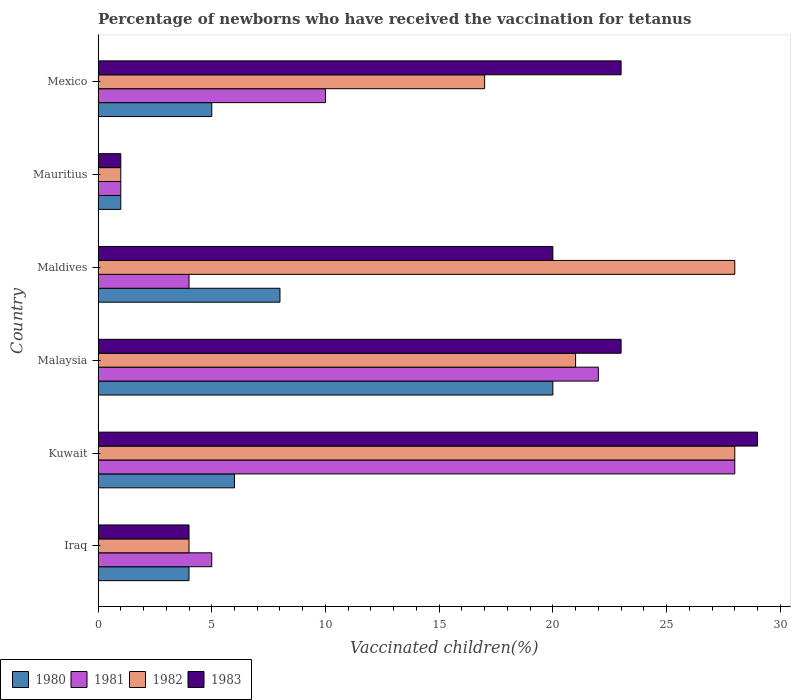How many different coloured bars are there?
Your answer should be very brief. 4. How many groups of bars are there?
Your answer should be compact. 6. How many bars are there on the 3rd tick from the top?
Offer a very short reply. 4. What is the label of the 3rd group of bars from the top?
Your response must be concise. Maldives. What is the percentage of vaccinated children in 1981 in Kuwait?
Offer a very short reply. 28. Across all countries, what is the minimum percentage of vaccinated children in 1982?
Your answer should be compact. 1. In which country was the percentage of vaccinated children in 1981 maximum?
Make the answer very short. Kuwait. In which country was the percentage of vaccinated children in 1980 minimum?
Your answer should be very brief. Mauritius. What is the total percentage of vaccinated children in 1982 in the graph?
Offer a very short reply. 99. What is the average percentage of vaccinated children in 1983 per country?
Make the answer very short. 16.67. What is the ratio of the percentage of vaccinated children in 1982 in Malaysia to that in Mauritius?
Make the answer very short. 21. Is the difference between the percentage of vaccinated children in 1983 in Kuwait and Mexico greater than the difference between the percentage of vaccinated children in 1981 in Kuwait and Mexico?
Make the answer very short. No. What is the difference between the highest and the second highest percentage of vaccinated children in 1982?
Make the answer very short. 0. Is the sum of the percentage of vaccinated children in 1983 in Iraq and Mauritius greater than the maximum percentage of vaccinated children in 1982 across all countries?
Offer a very short reply. No. Is it the case that in every country, the sum of the percentage of vaccinated children in 1983 and percentage of vaccinated children in 1982 is greater than the sum of percentage of vaccinated children in 1981 and percentage of vaccinated children in 1980?
Your response must be concise. No. What does the 1st bar from the bottom in Maldives represents?
Your response must be concise. 1980. How many bars are there?
Offer a very short reply. 24. Are all the bars in the graph horizontal?
Keep it short and to the point. Yes. What is the difference between two consecutive major ticks on the X-axis?
Provide a succinct answer. 5. Where does the legend appear in the graph?
Provide a succinct answer. Bottom left. How many legend labels are there?
Your answer should be very brief. 4. What is the title of the graph?
Keep it short and to the point. Percentage of newborns who have received the vaccination for tetanus. What is the label or title of the X-axis?
Provide a succinct answer. Vaccinated children(%). What is the Vaccinated children(%) of 1980 in Iraq?
Provide a short and direct response. 4. What is the Vaccinated children(%) in 1981 in Iraq?
Your response must be concise. 5. What is the Vaccinated children(%) of 1981 in Kuwait?
Your answer should be compact. 28. What is the Vaccinated children(%) of 1982 in Kuwait?
Your response must be concise. 28. What is the Vaccinated children(%) in 1980 in Malaysia?
Offer a very short reply. 20. What is the Vaccinated children(%) in 1983 in Malaysia?
Provide a succinct answer. 23. What is the Vaccinated children(%) of 1980 in Mauritius?
Give a very brief answer. 1. What is the Vaccinated children(%) in 1982 in Mauritius?
Offer a terse response. 1. What is the Vaccinated children(%) of 1980 in Mexico?
Give a very brief answer. 5. Across all countries, what is the maximum Vaccinated children(%) of 1982?
Your answer should be very brief. 28. Across all countries, what is the minimum Vaccinated children(%) of 1980?
Give a very brief answer. 1. Across all countries, what is the minimum Vaccinated children(%) of 1982?
Give a very brief answer. 1. Across all countries, what is the minimum Vaccinated children(%) in 1983?
Your answer should be very brief. 1. What is the difference between the Vaccinated children(%) of 1980 in Iraq and that in Kuwait?
Ensure brevity in your answer.  -2. What is the difference between the Vaccinated children(%) of 1981 in Iraq and that in Kuwait?
Your response must be concise. -23. What is the difference between the Vaccinated children(%) in 1983 in Iraq and that in Kuwait?
Make the answer very short. -25. What is the difference between the Vaccinated children(%) in 1980 in Iraq and that in Malaysia?
Your answer should be compact. -16. What is the difference between the Vaccinated children(%) in 1980 in Iraq and that in Maldives?
Your answer should be compact. -4. What is the difference between the Vaccinated children(%) in 1982 in Iraq and that in Maldives?
Offer a terse response. -24. What is the difference between the Vaccinated children(%) in 1983 in Iraq and that in Maldives?
Keep it short and to the point. -16. What is the difference between the Vaccinated children(%) in 1980 in Iraq and that in Mauritius?
Your answer should be very brief. 3. What is the difference between the Vaccinated children(%) in 1981 in Iraq and that in Mauritius?
Provide a succinct answer. 4. What is the difference between the Vaccinated children(%) of 1981 in Iraq and that in Mexico?
Your answer should be compact. -5. What is the difference between the Vaccinated children(%) in 1983 in Iraq and that in Mexico?
Give a very brief answer. -19. What is the difference between the Vaccinated children(%) in 1980 in Kuwait and that in Malaysia?
Make the answer very short. -14. What is the difference between the Vaccinated children(%) of 1983 in Kuwait and that in Malaysia?
Provide a succinct answer. 6. What is the difference between the Vaccinated children(%) of 1980 in Kuwait and that in Mexico?
Your answer should be compact. 1. What is the difference between the Vaccinated children(%) of 1981 in Kuwait and that in Mexico?
Your response must be concise. 18. What is the difference between the Vaccinated children(%) of 1982 in Kuwait and that in Mexico?
Your answer should be compact. 11. What is the difference between the Vaccinated children(%) in 1983 in Kuwait and that in Mexico?
Make the answer very short. 6. What is the difference between the Vaccinated children(%) of 1980 in Malaysia and that in Maldives?
Keep it short and to the point. 12. What is the difference between the Vaccinated children(%) of 1982 in Malaysia and that in Maldives?
Ensure brevity in your answer.  -7. What is the difference between the Vaccinated children(%) in 1980 in Malaysia and that in Mauritius?
Your answer should be very brief. 19. What is the difference between the Vaccinated children(%) in 1981 in Malaysia and that in Mauritius?
Ensure brevity in your answer.  21. What is the difference between the Vaccinated children(%) in 1983 in Malaysia and that in Mexico?
Your answer should be very brief. 0. What is the difference between the Vaccinated children(%) in 1983 in Maldives and that in Mauritius?
Keep it short and to the point. 19. What is the difference between the Vaccinated children(%) in 1981 in Maldives and that in Mexico?
Provide a short and direct response. -6. What is the difference between the Vaccinated children(%) of 1982 in Maldives and that in Mexico?
Ensure brevity in your answer.  11. What is the difference between the Vaccinated children(%) of 1980 in Mauritius and that in Mexico?
Provide a short and direct response. -4. What is the difference between the Vaccinated children(%) in 1981 in Mauritius and that in Mexico?
Ensure brevity in your answer.  -9. What is the difference between the Vaccinated children(%) in 1982 in Mauritius and that in Mexico?
Provide a succinct answer. -16. What is the difference between the Vaccinated children(%) in 1980 in Iraq and the Vaccinated children(%) in 1982 in Kuwait?
Provide a succinct answer. -24. What is the difference between the Vaccinated children(%) in 1980 in Iraq and the Vaccinated children(%) in 1983 in Kuwait?
Make the answer very short. -25. What is the difference between the Vaccinated children(%) in 1981 in Iraq and the Vaccinated children(%) in 1983 in Kuwait?
Ensure brevity in your answer.  -24. What is the difference between the Vaccinated children(%) in 1982 in Iraq and the Vaccinated children(%) in 1983 in Kuwait?
Your answer should be compact. -25. What is the difference between the Vaccinated children(%) of 1980 in Iraq and the Vaccinated children(%) of 1982 in Malaysia?
Provide a short and direct response. -17. What is the difference between the Vaccinated children(%) of 1981 in Iraq and the Vaccinated children(%) of 1982 in Malaysia?
Your answer should be compact. -16. What is the difference between the Vaccinated children(%) of 1981 in Iraq and the Vaccinated children(%) of 1983 in Malaysia?
Offer a terse response. -18. What is the difference between the Vaccinated children(%) of 1980 in Iraq and the Vaccinated children(%) of 1983 in Maldives?
Provide a short and direct response. -16. What is the difference between the Vaccinated children(%) of 1981 in Iraq and the Vaccinated children(%) of 1982 in Maldives?
Your answer should be very brief. -23. What is the difference between the Vaccinated children(%) in 1981 in Iraq and the Vaccinated children(%) in 1983 in Maldives?
Make the answer very short. -15. What is the difference between the Vaccinated children(%) in 1982 in Iraq and the Vaccinated children(%) in 1983 in Maldives?
Keep it short and to the point. -16. What is the difference between the Vaccinated children(%) in 1980 in Iraq and the Vaccinated children(%) in 1981 in Mauritius?
Give a very brief answer. 3. What is the difference between the Vaccinated children(%) of 1981 in Iraq and the Vaccinated children(%) of 1982 in Mauritius?
Provide a short and direct response. 4. What is the difference between the Vaccinated children(%) in 1982 in Iraq and the Vaccinated children(%) in 1983 in Mauritius?
Your answer should be compact. 3. What is the difference between the Vaccinated children(%) of 1980 in Iraq and the Vaccinated children(%) of 1981 in Mexico?
Provide a succinct answer. -6. What is the difference between the Vaccinated children(%) in 1980 in Iraq and the Vaccinated children(%) in 1982 in Mexico?
Your answer should be compact. -13. What is the difference between the Vaccinated children(%) in 1981 in Iraq and the Vaccinated children(%) in 1983 in Mexico?
Give a very brief answer. -18. What is the difference between the Vaccinated children(%) in 1982 in Iraq and the Vaccinated children(%) in 1983 in Mexico?
Keep it short and to the point. -19. What is the difference between the Vaccinated children(%) in 1980 in Kuwait and the Vaccinated children(%) in 1981 in Malaysia?
Your answer should be very brief. -16. What is the difference between the Vaccinated children(%) of 1980 in Kuwait and the Vaccinated children(%) of 1982 in Malaysia?
Ensure brevity in your answer.  -15. What is the difference between the Vaccinated children(%) in 1980 in Kuwait and the Vaccinated children(%) in 1983 in Malaysia?
Provide a succinct answer. -17. What is the difference between the Vaccinated children(%) in 1981 in Kuwait and the Vaccinated children(%) in 1983 in Malaysia?
Offer a very short reply. 5. What is the difference between the Vaccinated children(%) of 1981 in Kuwait and the Vaccinated children(%) of 1982 in Maldives?
Offer a terse response. 0. What is the difference between the Vaccinated children(%) of 1981 in Kuwait and the Vaccinated children(%) of 1983 in Maldives?
Give a very brief answer. 8. What is the difference between the Vaccinated children(%) of 1982 in Kuwait and the Vaccinated children(%) of 1983 in Maldives?
Keep it short and to the point. 8. What is the difference between the Vaccinated children(%) in 1981 in Kuwait and the Vaccinated children(%) in 1983 in Mauritius?
Your answer should be compact. 27. What is the difference between the Vaccinated children(%) in 1980 in Kuwait and the Vaccinated children(%) in 1982 in Mexico?
Your answer should be compact. -11. What is the difference between the Vaccinated children(%) in 1980 in Kuwait and the Vaccinated children(%) in 1983 in Mexico?
Ensure brevity in your answer.  -17. What is the difference between the Vaccinated children(%) of 1981 in Kuwait and the Vaccinated children(%) of 1982 in Mexico?
Your answer should be compact. 11. What is the difference between the Vaccinated children(%) in 1980 in Malaysia and the Vaccinated children(%) in 1982 in Maldives?
Give a very brief answer. -8. What is the difference between the Vaccinated children(%) in 1981 in Malaysia and the Vaccinated children(%) in 1982 in Maldives?
Provide a short and direct response. -6. What is the difference between the Vaccinated children(%) in 1982 in Malaysia and the Vaccinated children(%) in 1983 in Maldives?
Your response must be concise. 1. What is the difference between the Vaccinated children(%) in 1980 in Malaysia and the Vaccinated children(%) in 1981 in Mauritius?
Provide a succinct answer. 19. What is the difference between the Vaccinated children(%) of 1981 in Malaysia and the Vaccinated children(%) of 1982 in Mauritius?
Provide a short and direct response. 21. What is the difference between the Vaccinated children(%) of 1981 in Malaysia and the Vaccinated children(%) of 1983 in Mauritius?
Make the answer very short. 21. What is the difference between the Vaccinated children(%) in 1982 in Malaysia and the Vaccinated children(%) in 1983 in Mauritius?
Offer a terse response. 20. What is the difference between the Vaccinated children(%) in 1980 in Malaysia and the Vaccinated children(%) in 1981 in Mexico?
Make the answer very short. 10. What is the difference between the Vaccinated children(%) of 1980 in Malaysia and the Vaccinated children(%) of 1982 in Mexico?
Make the answer very short. 3. What is the difference between the Vaccinated children(%) in 1980 in Malaysia and the Vaccinated children(%) in 1983 in Mexico?
Your response must be concise. -3. What is the difference between the Vaccinated children(%) of 1981 in Malaysia and the Vaccinated children(%) of 1983 in Mexico?
Give a very brief answer. -1. What is the difference between the Vaccinated children(%) of 1980 in Maldives and the Vaccinated children(%) of 1981 in Mauritius?
Give a very brief answer. 7. What is the difference between the Vaccinated children(%) in 1980 in Maldives and the Vaccinated children(%) in 1982 in Mauritius?
Provide a short and direct response. 7. What is the difference between the Vaccinated children(%) in 1980 in Maldives and the Vaccinated children(%) in 1983 in Mauritius?
Ensure brevity in your answer.  7. What is the difference between the Vaccinated children(%) in 1981 in Maldives and the Vaccinated children(%) in 1982 in Mauritius?
Keep it short and to the point. 3. What is the difference between the Vaccinated children(%) of 1981 in Maldives and the Vaccinated children(%) of 1983 in Mauritius?
Give a very brief answer. 3. What is the difference between the Vaccinated children(%) of 1980 in Maldives and the Vaccinated children(%) of 1983 in Mexico?
Ensure brevity in your answer.  -15. What is the difference between the Vaccinated children(%) in 1981 in Maldives and the Vaccinated children(%) in 1982 in Mexico?
Keep it short and to the point. -13. What is the difference between the Vaccinated children(%) in 1981 in Maldives and the Vaccinated children(%) in 1983 in Mexico?
Offer a very short reply. -19. What is the difference between the Vaccinated children(%) in 1982 in Maldives and the Vaccinated children(%) in 1983 in Mexico?
Your response must be concise. 5. What is the difference between the Vaccinated children(%) of 1980 in Mauritius and the Vaccinated children(%) of 1982 in Mexico?
Keep it short and to the point. -16. What is the difference between the Vaccinated children(%) in 1982 in Mauritius and the Vaccinated children(%) in 1983 in Mexico?
Give a very brief answer. -22. What is the average Vaccinated children(%) of 1980 per country?
Your response must be concise. 7.33. What is the average Vaccinated children(%) of 1981 per country?
Offer a very short reply. 11.67. What is the average Vaccinated children(%) of 1983 per country?
Your response must be concise. 16.67. What is the difference between the Vaccinated children(%) in 1980 and Vaccinated children(%) in 1981 in Iraq?
Your answer should be very brief. -1. What is the difference between the Vaccinated children(%) in 1980 and Vaccinated children(%) in 1982 in Iraq?
Your answer should be compact. 0. What is the difference between the Vaccinated children(%) of 1980 and Vaccinated children(%) of 1981 in Malaysia?
Provide a short and direct response. -2. What is the difference between the Vaccinated children(%) of 1981 and Vaccinated children(%) of 1982 in Malaysia?
Offer a very short reply. 1. What is the difference between the Vaccinated children(%) of 1981 and Vaccinated children(%) of 1983 in Malaysia?
Your response must be concise. -1. What is the difference between the Vaccinated children(%) in 1980 and Vaccinated children(%) in 1981 in Maldives?
Provide a succinct answer. 4. What is the difference between the Vaccinated children(%) in 1980 and Vaccinated children(%) in 1983 in Maldives?
Your answer should be very brief. -12. What is the difference between the Vaccinated children(%) of 1981 and Vaccinated children(%) of 1983 in Maldives?
Provide a short and direct response. -16. What is the difference between the Vaccinated children(%) in 1982 and Vaccinated children(%) in 1983 in Maldives?
Your answer should be compact. 8. What is the difference between the Vaccinated children(%) in 1980 and Vaccinated children(%) in 1982 in Mauritius?
Make the answer very short. 0. What is the difference between the Vaccinated children(%) in 1980 and Vaccinated children(%) in 1983 in Mauritius?
Ensure brevity in your answer.  0. What is the difference between the Vaccinated children(%) in 1982 and Vaccinated children(%) in 1983 in Mauritius?
Offer a terse response. 0. What is the difference between the Vaccinated children(%) of 1980 and Vaccinated children(%) of 1981 in Mexico?
Give a very brief answer. -5. What is the difference between the Vaccinated children(%) in 1981 and Vaccinated children(%) in 1983 in Mexico?
Provide a short and direct response. -13. What is the ratio of the Vaccinated children(%) of 1980 in Iraq to that in Kuwait?
Your response must be concise. 0.67. What is the ratio of the Vaccinated children(%) in 1981 in Iraq to that in Kuwait?
Provide a short and direct response. 0.18. What is the ratio of the Vaccinated children(%) of 1982 in Iraq to that in Kuwait?
Your response must be concise. 0.14. What is the ratio of the Vaccinated children(%) in 1983 in Iraq to that in Kuwait?
Provide a succinct answer. 0.14. What is the ratio of the Vaccinated children(%) of 1980 in Iraq to that in Malaysia?
Make the answer very short. 0.2. What is the ratio of the Vaccinated children(%) of 1981 in Iraq to that in Malaysia?
Your answer should be very brief. 0.23. What is the ratio of the Vaccinated children(%) in 1982 in Iraq to that in Malaysia?
Give a very brief answer. 0.19. What is the ratio of the Vaccinated children(%) of 1983 in Iraq to that in Malaysia?
Your response must be concise. 0.17. What is the ratio of the Vaccinated children(%) in 1981 in Iraq to that in Maldives?
Ensure brevity in your answer.  1.25. What is the ratio of the Vaccinated children(%) of 1982 in Iraq to that in Maldives?
Offer a terse response. 0.14. What is the ratio of the Vaccinated children(%) of 1983 in Iraq to that in Maldives?
Offer a very short reply. 0.2. What is the ratio of the Vaccinated children(%) of 1980 in Iraq to that in Mauritius?
Provide a succinct answer. 4. What is the ratio of the Vaccinated children(%) in 1981 in Iraq to that in Mauritius?
Offer a very short reply. 5. What is the ratio of the Vaccinated children(%) in 1982 in Iraq to that in Mauritius?
Ensure brevity in your answer.  4. What is the ratio of the Vaccinated children(%) in 1981 in Iraq to that in Mexico?
Keep it short and to the point. 0.5. What is the ratio of the Vaccinated children(%) in 1982 in Iraq to that in Mexico?
Give a very brief answer. 0.24. What is the ratio of the Vaccinated children(%) in 1983 in Iraq to that in Mexico?
Provide a short and direct response. 0.17. What is the ratio of the Vaccinated children(%) in 1980 in Kuwait to that in Malaysia?
Provide a succinct answer. 0.3. What is the ratio of the Vaccinated children(%) in 1981 in Kuwait to that in Malaysia?
Ensure brevity in your answer.  1.27. What is the ratio of the Vaccinated children(%) in 1982 in Kuwait to that in Malaysia?
Your response must be concise. 1.33. What is the ratio of the Vaccinated children(%) in 1983 in Kuwait to that in Malaysia?
Your response must be concise. 1.26. What is the ratio of the Vaccinated children(%) of 1980 in Kuwait to that in Maldives?
Ensure brevity in your answer.  0.75. What is the ratio of the Vaccinated children(%) of 1982 in Kuwait to that in Maldives?
Provide a short and direct response. 1. What is the ratio of the Vaccinated children(%) of 1983 in Kuwait to that in Maldives?
Provide a succinct answer. 1.45. What is the ratio of the Vaccinated children(%) in 1982 in Kuwait to that in Mexico?
Provide a short and direct response. 1.65. What is the ratio of the Vaccinated children(%) of 1983 in Kuwait to that in Mexico?
Keep it short and to the point. 1.26. What is the ratio of the Vaccinated children(%) of 1982 in Malaysia to that in Maldives?
Provide a succinct answer. 0.75. What is the ratio of the Vaccinated children(%) in 1983 in Malaysia to that in Maldives?
Ensure brevity in your answer.  1.15. What is the ratio of the Vaccinated children(%) of 1980 in Malaysia to that in Mauritius?
Keep it short and to the point. 20. What is the ratio of the Vaccinated children(%) of 1982 in Malaysia to that in Mauritius?
Ensure brevity in your answer.  21. What is the ratio of the Vaccinated children(%) of 1983 in Malaysia to that in Mauritius?
Your answer should be very brief. 23. What is the ratio of the Vaccinated children(%) of 1980 in Malaysia to that in Mexico?
Your response must be concise. 4. What is the ratio of the Vaccinated children(%) of 1982 in Malaysia to that in Mexico?
Make the answer very short. 1.24. What is the ratio of the Vaccinated children(%) in 1983 in Malaysia to that in Mexico?
Ensure brevity in your answer.  1. What is the ratio of the Vaccinated children(%) in 1981 in Maldives to that in Mauritius?
Your answer should be compact. 4. What is the ratio of the Vaccinated children(%) in 1983 in Maldives to that in Mauritius?
Offer a very short reply. 20. What is the ratio of the Vaccinated children(%) of 1982 in Maldives to that in Mexico?
Your answer should be very brief. 1.65. What is the ratio of the Vaccinated children(%) of 1983 in Maldives to that in Mexico?
Keep it short and to the point. 0.87. What is the ratio of the Vaccinated children(%) in 1980 in Mauritius to that in Mexico?
Your response must be concise. 0.2. What is the ratio of the Vaccinated children(%) in 1981 in Mauritius to that in Mexico?
Ensure brevity in your answer.  0.1. What is the ratio of the Vaccinated children(%) of 1982 in Mauritius to that in Mexico?
Keep it short and to the point. 0.06. What is the ratio of the Vaccinated children(%) of 1983 in Mauritius to that in Mexico?
Offer a very short reply. 0.04. What is the difference between the highest and the second highest Vaccinated children(%) of 1982?
Make the answer very short. 0. What is the difference between the highest and the lowest Vaccinated children(%) in 1981?
Ensure brevity in your answer.  27. 